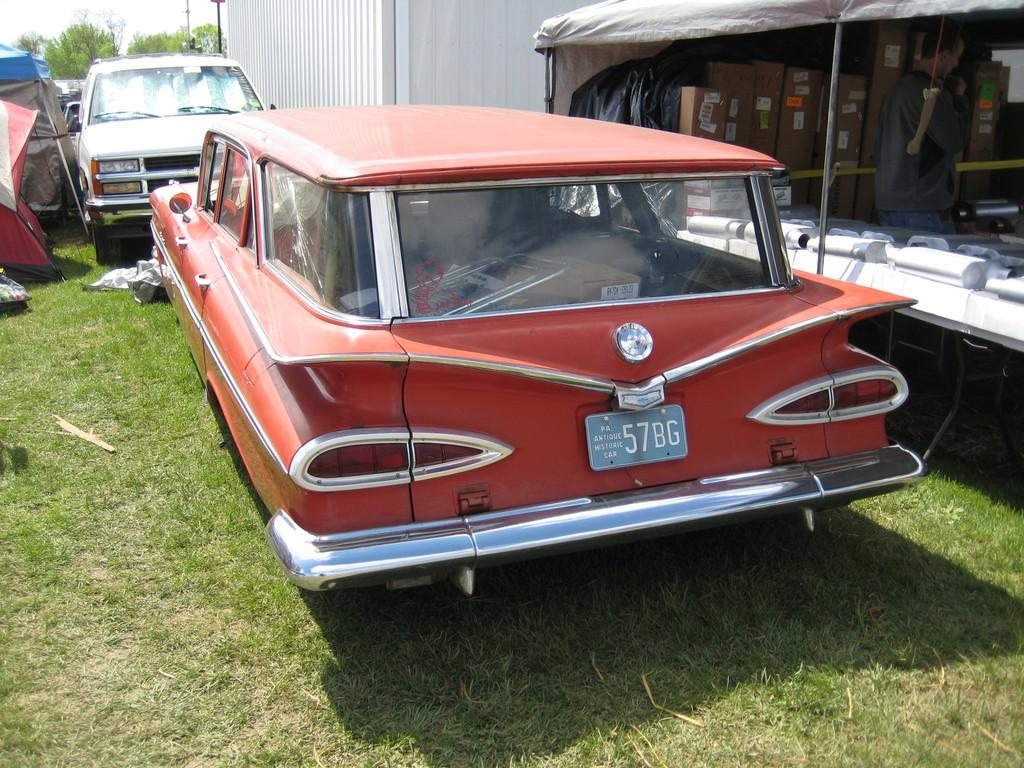What can be seen in the middle of the image? There are two cars parked on the ground in the middle of the image. What type of surface are the cars parked on? The cars are parked on grass, which is visible on the ground. What can be seen in the background of the image? There are trees in the background of the image. What type of yarn is being used to support the trees in the image? There is no yarn or support system visible for the trees in the image; they are standing on their own. 